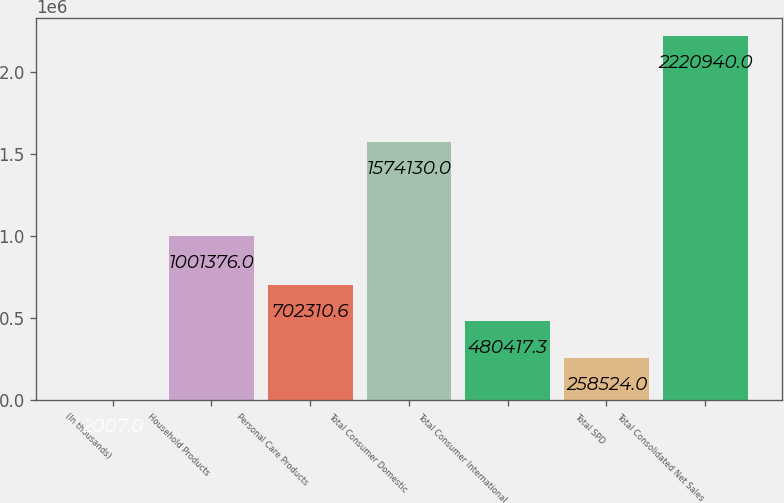<chart> <loc_0><loc_0><loc_500><loc_500><bar_chart><fcel>(In thousands)<fcel>Household Products<fcel>Personal Care Products<fcel>Total Consumer Domestic<fcel>Total Consumer International<fcel>Total SPD<fcel>Total Consolidated Net Sales<nl><fcel>2007<fcel>1.00138e+06<fcel>702311<fcel>1.57413e+06<fcel>480417<fcel>258524<fcel>2.22094e+06<nl></chart> 